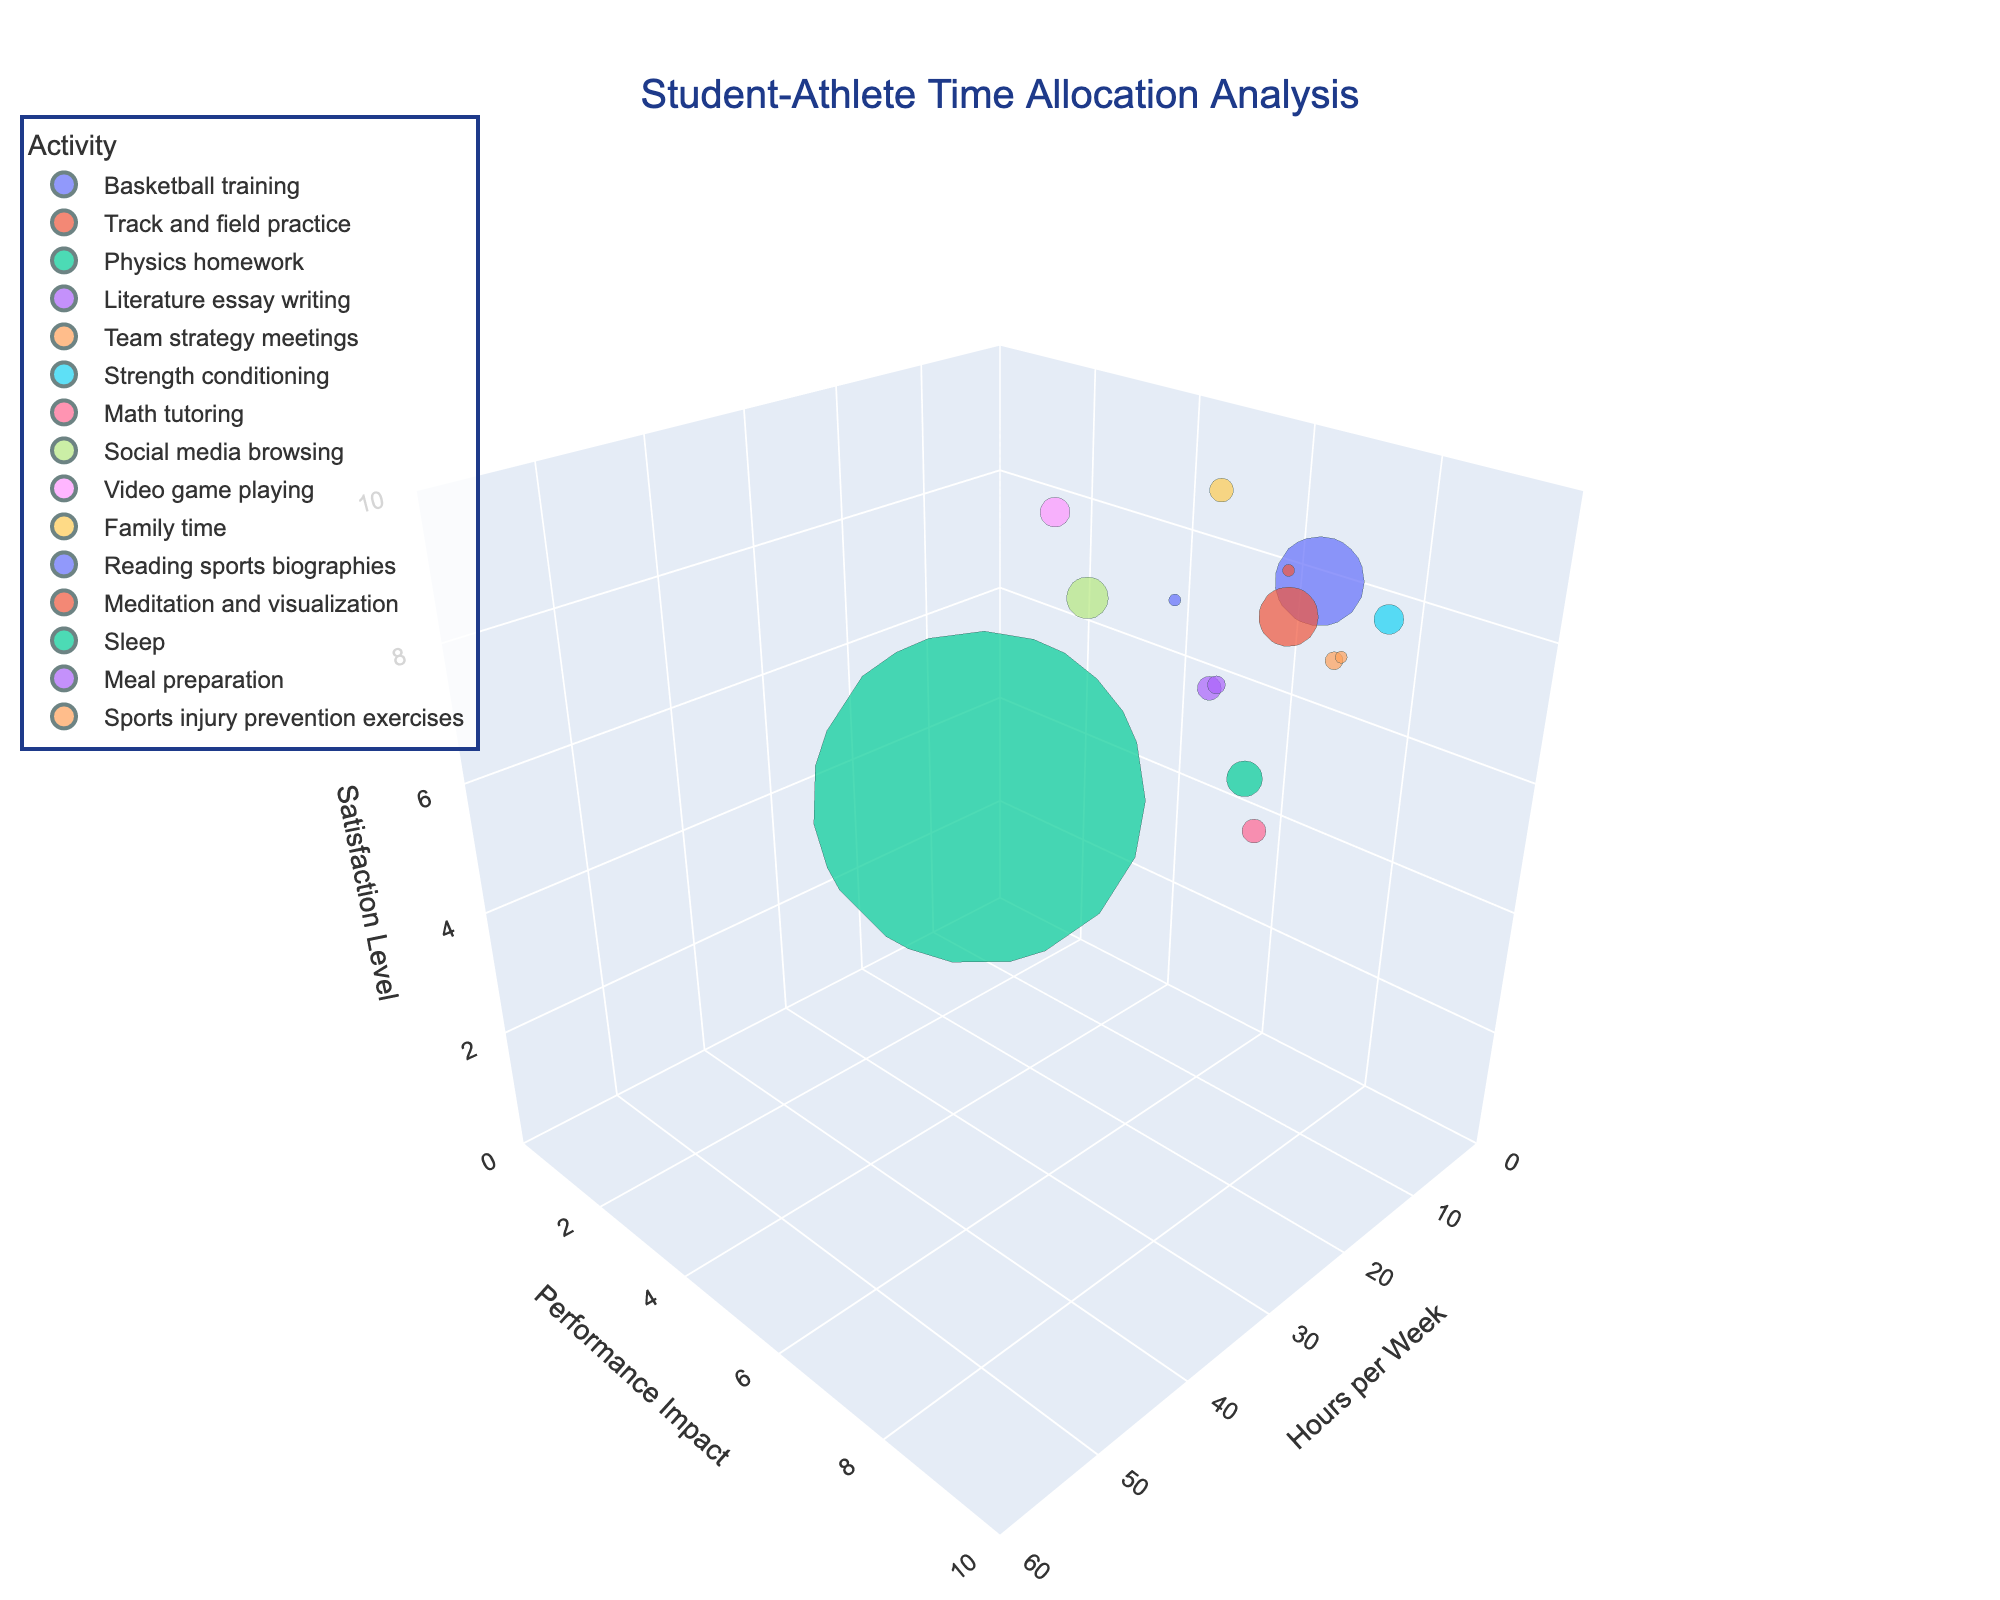What is the title of the chart? The title of the chart is displayed at the top center and it summarizes the main focus of the chart. The title here is "Student-Athlete Time Allocation Analysis".
Answer: Student-Athlete Time Allocation Analysis What are the labels for the axes in the chart? The labels for the axes are indicated at the ends of each axis. The x-axis is labeled as 'Hours per Week', the y-axis as 'Performance Impact', and the z-axis as 'Satisfaction Level'.
Answer: Hours per Week, Performance Impact, Satisfaction Level Which activity has the highest 'Hours per week' value? To find the activity with the highest 'Hours per week' value, look for the bubble that is farthest along the x-axis. The activity is 'Sleep' with 56 hours per week.
Answer: Sleep What is the 'Performance impact' of 'Basketball training'? Identify the bubble for 'Basketball training' and see where it aligns along the y-axis, which represents 'Performance impact'. It is located at 8.
Answer: 8 Which activity has the smallest bubble size? Bubble size corresponds to 'Hours per week'. The smallest bubble represents the activity with the least hours, which is 'Reading sports biographies' and 'Meditation and visualization', both with 2 hours.
Answer: Reading sports biographies, Meditation and visualization What is the overall range for 'Satisfaction level' in the chart? The range is determined by the lowest and highest 'Satisfaction level' points on the z-axis. The lowest level is 2 and the highest is 9.
Answer: 2 to 9 Which activities have a 'Performance impact' of 7? Check along the y-axis for 'Performance impact' value of 7 and identify the corresponding activities. They are 'Track and field practice', 'Team strategy meetings', and 'Sports injury prevention exercises'.
Answer: Track and field practice, Team strategy meetings, Sports injury prevention exercises Which activity provides the highest 'Satisfaction level' with the least 'Hours per week'? Find the bubble that is at the highest point on the z-axis (9 for 'Satisfaction level') and the smallest x-axis value (least 'Hours per week'). 'Family time' and 'Sleep' both have a satisfaction level of 9, but 'Family time' has the least hours at 4.
Answer: Family time How does the 'Performance impact' of 'Video game playing' compare to 'Math tutoring'? Locate the bubbles for both activities and compare their positions on the y-axis. 'Video game playing' has a 'Performance impact' of 2, and 'Math tutoring' has a 'Performance impact' of 6.
Answer: Math tutoring is higher What's the sum of 'Hours per week' for activities with 'Satisfaction levels' above 7? To find this, identify activities with 'Satisfaction levels' above 7 and sum their 'Hours per week'. These are 'Basketball training' (9), 'Track and field practice' (8), 'Strength conditioning' (8), 'Video game playing' (8), 'Meditation and visualization' (8), 'Family time' (9), and 'Sleep' (9). The sum is 15 + 10 + 5 + 5 + 2 + 4 + 56 = 97.
Answer: 97 